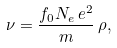<formula> <loc_0><loc_0><loc_500><loc_500>\nu = \frac { f _ { 0 } N _ { e } \, e ^ { 2 } } { m } \, \rho ,</formula> 